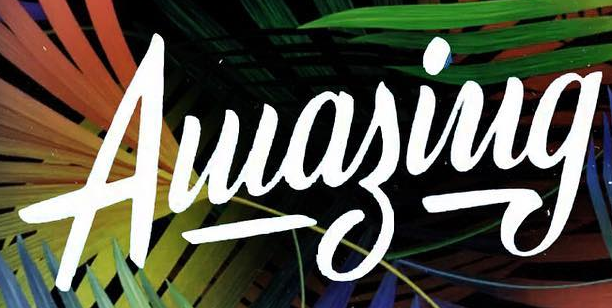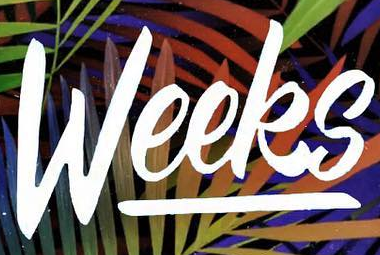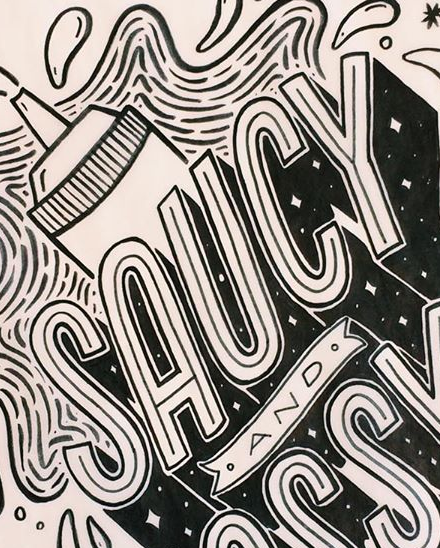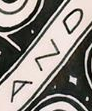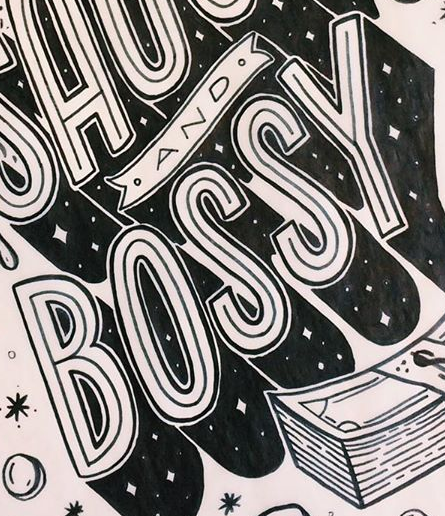What text is displayed in these images sequentially, separated by a semicolon? Aluagiug; Weeks; SAUCY; AND; BOSSY 